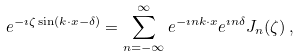<formula> <loc_0><loc_0><loc_500><loc_500>e ^ { - \imath \zeta \sin ( k \cdot x - \delta ) } = \sum _ { n = - \infty } ^ { \infty } e ^ { - \imath n k \cdot x } e ^ { \imath n \delta } J _ { n } ( \zeta ) \, ,</formula> 